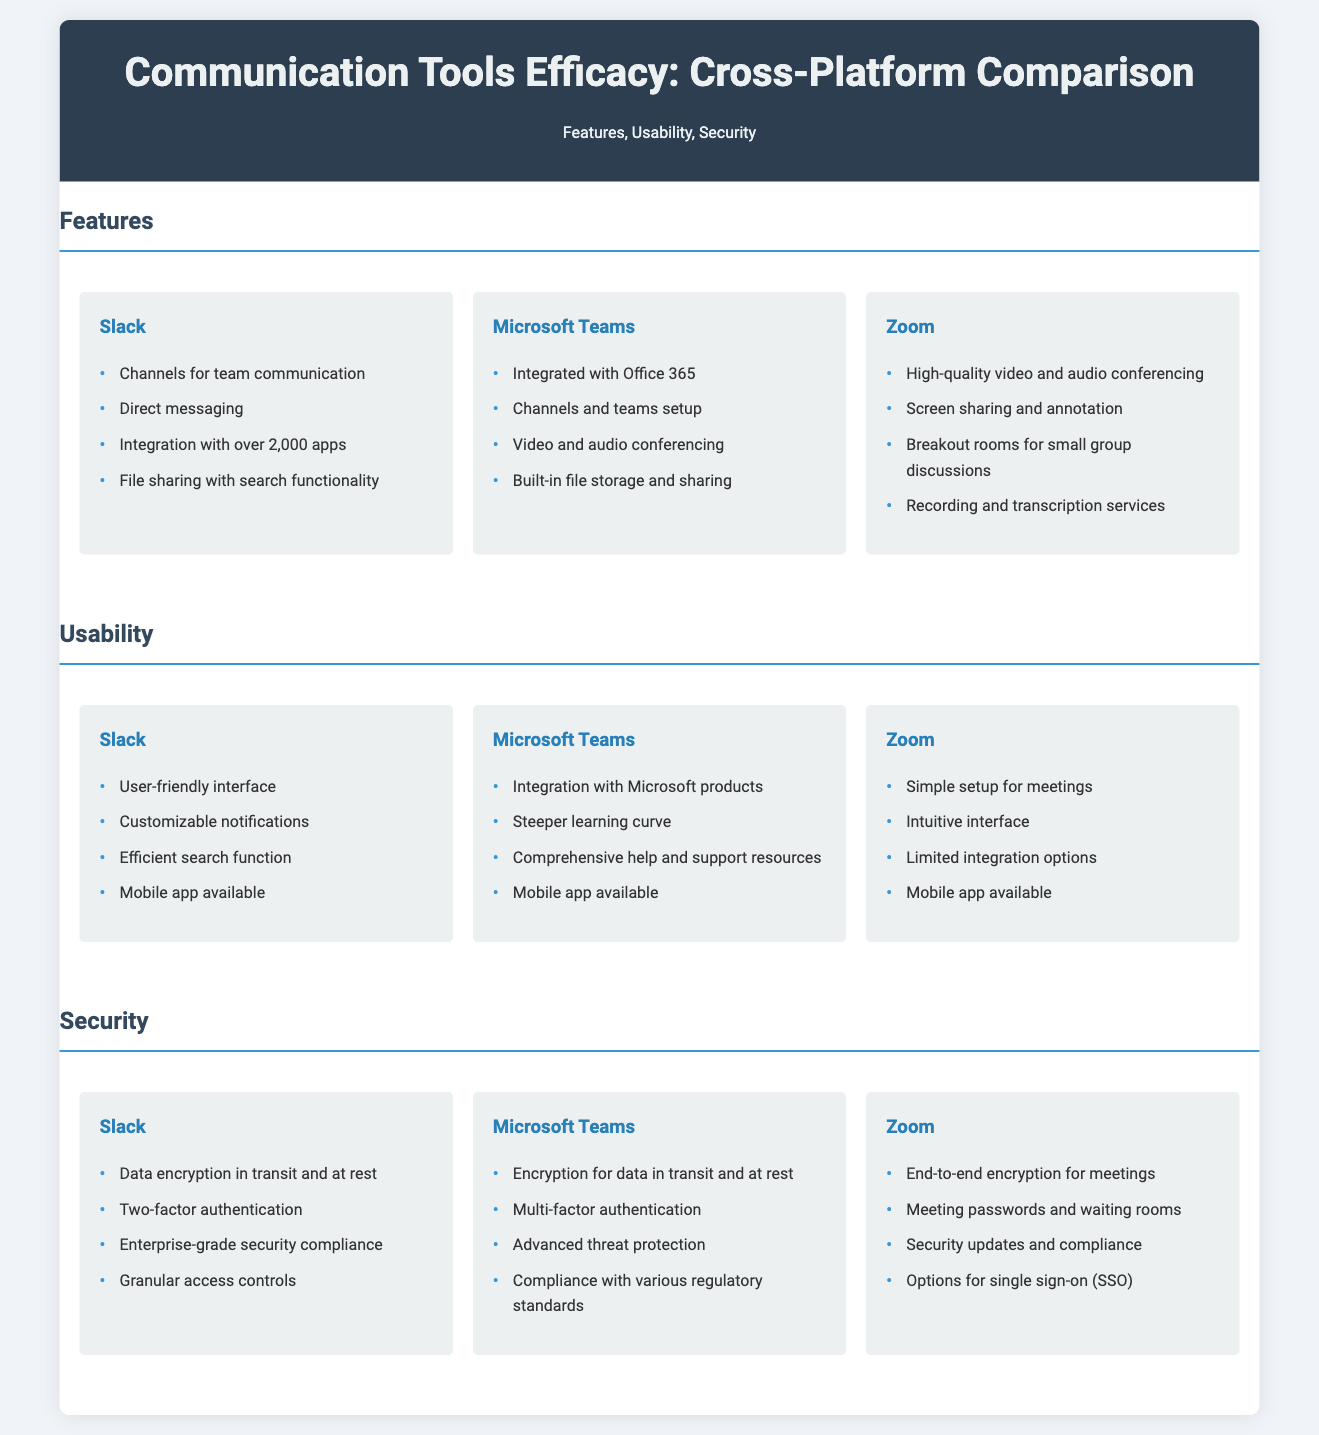What are the features of Slack? The document lists the features of Slack, including channels for team communication, direct messaging, integration with over 2,000 apps, and file sharing with search functionality.
Answer: Channels for team communication, direct messaging, integration with over 2,000 apps, file sharing with search functionality How many integration options does Zoom have? The document describes Zoom's features, stating it has limited integration options.
Answer: Limited What security feature does Microsoft Teams have for data? The document mentions that Microsoft Teams includes encryption for data in transit and at rest.
Answer: Encryption for data in transit and at rest Which platform has advanced threat protection? The document states that Microsoft Teams provides advanced threat protection as part of its security features.
Answer: Microsoft Teams Which tool offers breakout rooms for discussions? The document lists breakout rooms for small group discussions as a feature of Zoom.
Answer: Zoom What is a usability feature of Slack? The document highlights Slack's user-friendly interface as a key usability feature.
Answer: User-friendly interface Which communication tool has a steeper learning curve? The document states that Microsoft Teams has a steeper learning curve compared to other platforms.
Answer: Microsoft Teams What is the total number of platforms compared? The document compares three platforms: Slack, Microsoft Teams, and Zoom.
Answer: Three 